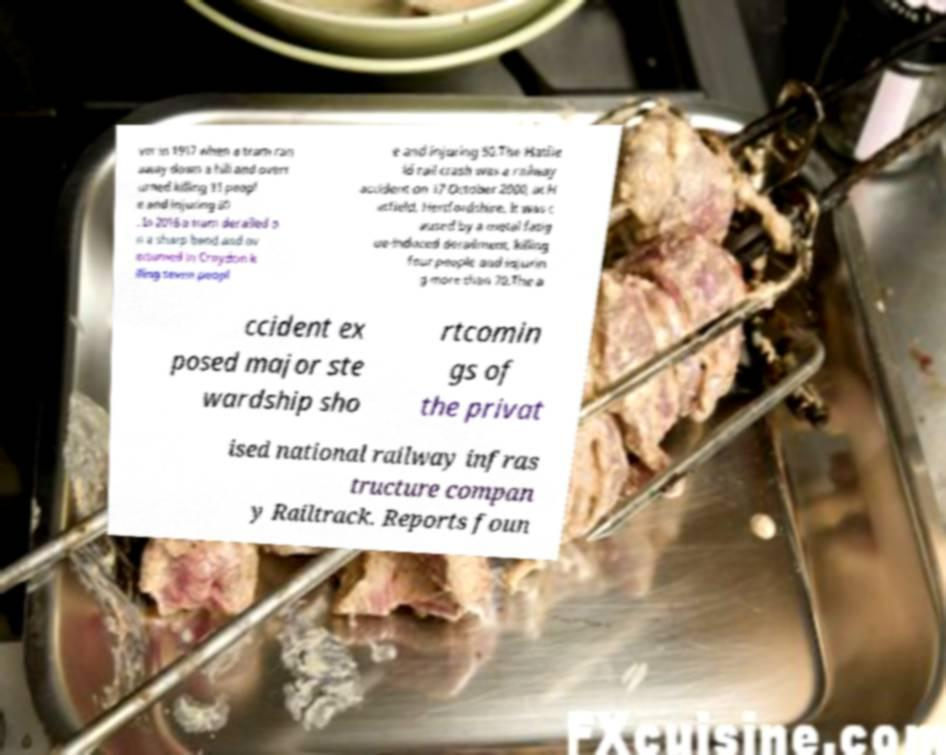Could you extract and type out the text from this image? ver in 1917 when a tram ran away down a hill and overt urned killing 11 peopl e and injuring 60 . In 2016 a tram derailed o n a sharp bend and ov erturned in Croydon k illing seven peopl e and injuring 50.The Hatfie ld rail crash was a railway accident on 17 October 2000, at H atfield, Hertfordshire. It was c aused by a metal fatig ue-induced derailment, killing four people and injurin g more than 70.The a ccident ex posed major ste wardship sho rtcomin gs of the privat ised national railway infras tructure compan y Railtrack. Reports foun 